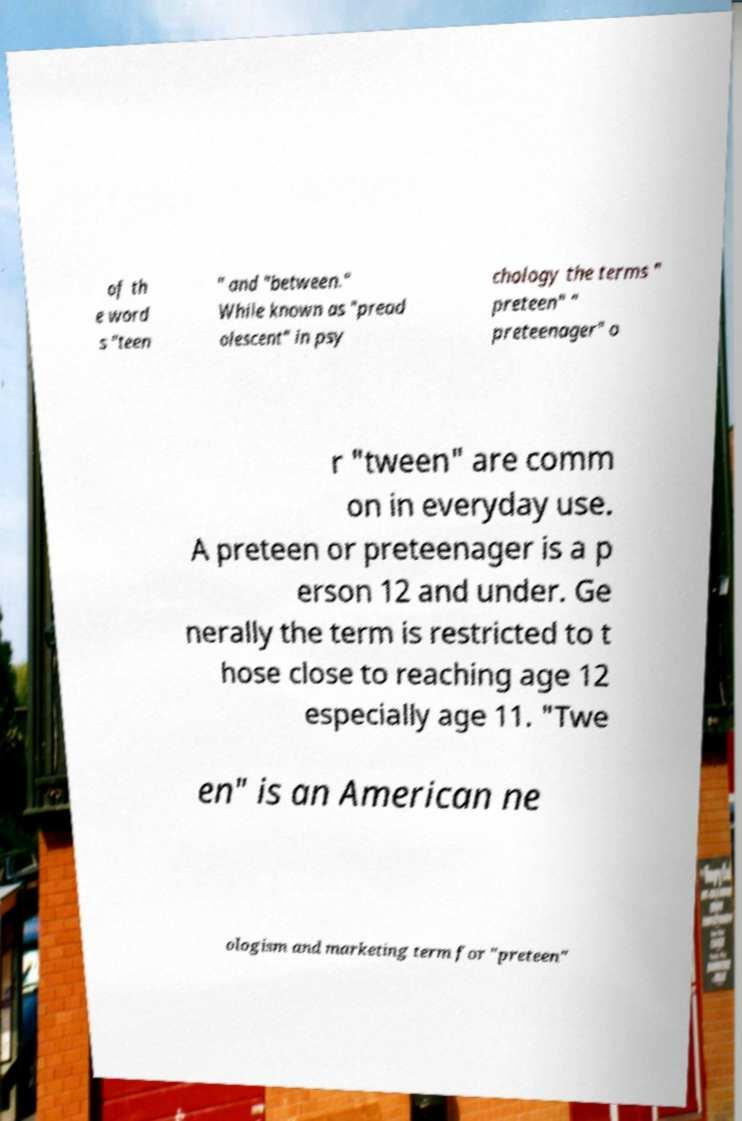I need the written content from this picture converted into text. Can you do that? of th e word s "teen " and "between." While known as "pread olescent" in psy chology the terms " preteen" " preteenager" o r "tween" are comm on in everyday use. A preteen or preteenager is a p erson 12 and under. Ge nerally the term is restricted to t hose close to reaching age 12 especially age 11. "Twe en" is an American ne ologism and marketing term for "preteen" 